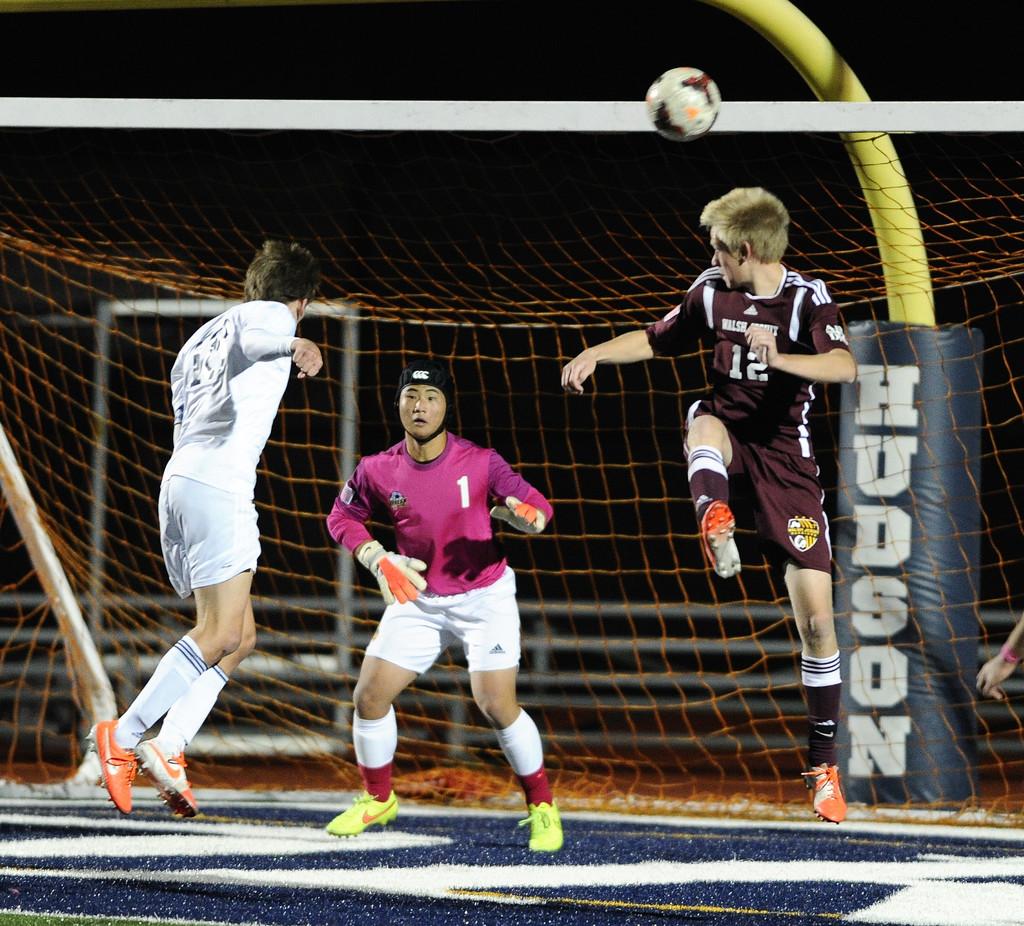What brand is on the pole?
Provide a succinct answer. Hudson. What jersey number is the man in the pink wearing?
Make the answer very short. 1. 